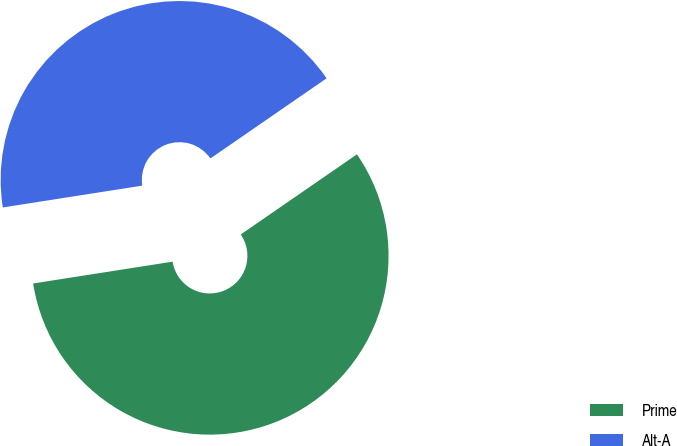<chart> <loc_0><loc_0><loc_500><loc_500><pie_chart><fcel>Prime<fcel>Alt-A<nl><fcel>57.14%<fcel>42.86%<nl></chart> 